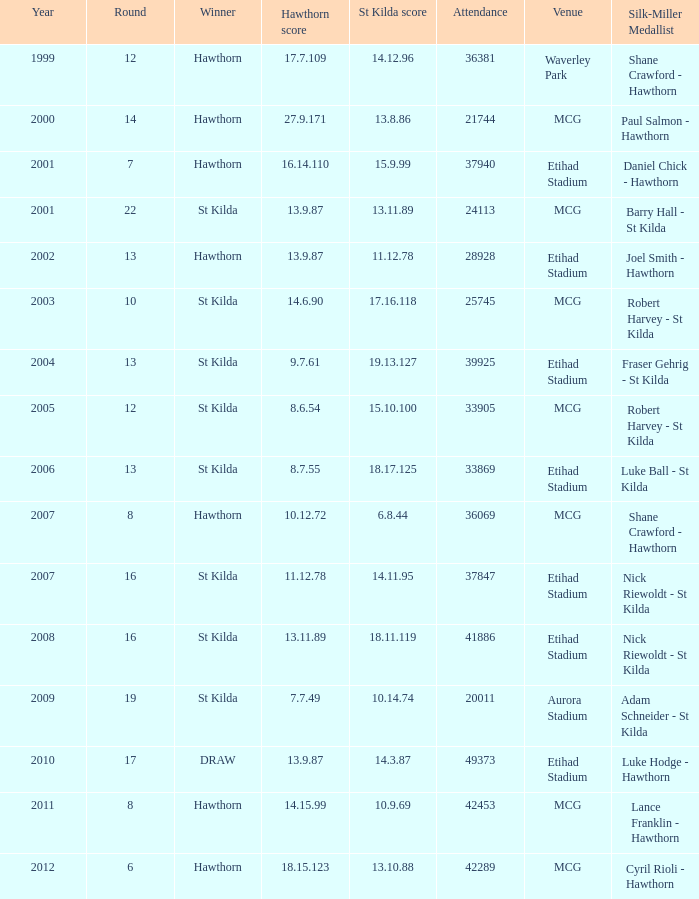Who is the winner when the st kilda score is 13.10.88? Hawthorn. 